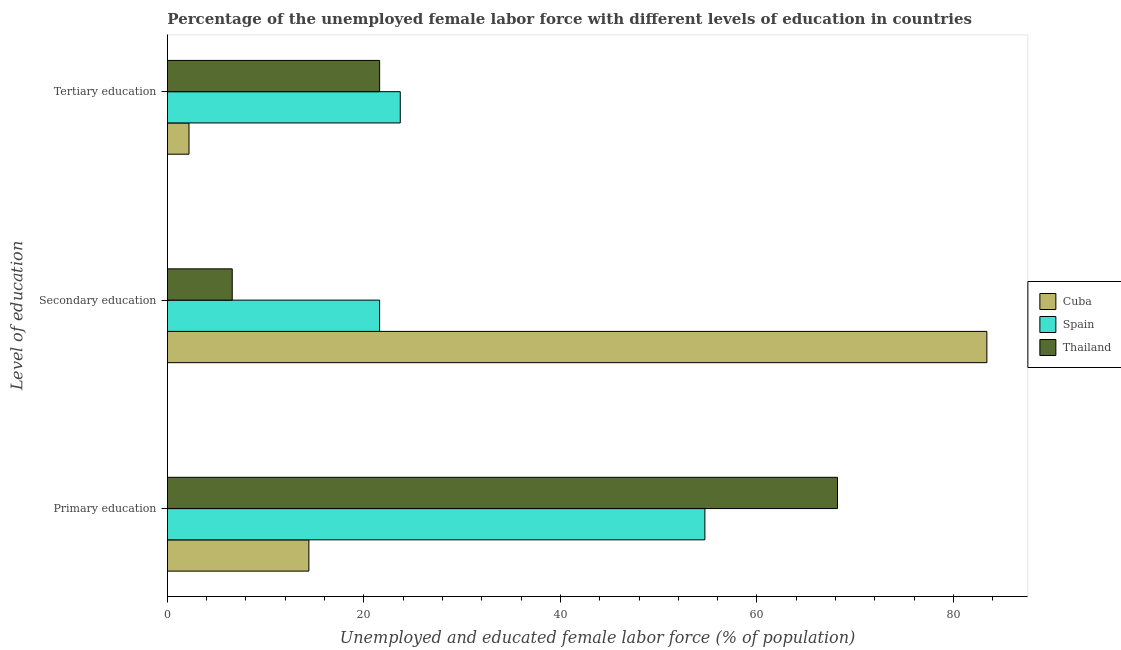How many groups of bars are there?
Give a very brief answer. 3. Are the number of bars per tick equal to the number of legend labels?
Offer a terse response. Yes. Are the number of bars on each tick of the Y-axis equal?
Provide a short and direct response. Yes. How many bars are there on the 2nd tick from the bottom?
Offer a terse response. 3. What is the percentage of female labor force who received tertiary education in Cuba?
Make the answer very short. 2.2. Across all countries, what is the maximum percentage of female labor force who received secondary education?
Offer a very short reply. 83.4. Across all countries, what is the minimum percentage of female labor force who received tertiary education?
Give a very brief answer. 2.2. In which country was the percentage of female labor force who received primary education maximum?
Your answer should be very brief. Thailand. In which country was the percentage of female labor force who received primary education minimum?
Keep it short and to the point. Cuba. What is the total percentage of female labor force who received primary education in the graph?
Keep it short and to the point. 137.3. What is the difference between the percentage of female labor force who received primary education in Thailand and that in Spain?
Your response must be concise. 13.5. What is the difference between the percentage of female labor force who received primary education in Cuba and the percentage of female labor force who received secondary education in Thailand?
Your response must be concise. 7.8. What is the average percentage of female labor force who received tertiary education per country?
Your answer should be very brief. 15.83. What is the difference between the percentage of female labor force who received secondary education and percentage of female labor force who received tertiary education in Cuba?
Ensure brevity in your answer.  81.2. In how many countries, is the percentage of female labor force who received tertiary education greater than 32 %?
Ensure brevity in your answer.  0. What is the ratio of the percentage of female labor force who received primary education in Spain to that in Cuba?
Your answer should be very brief. 3.8. Is the percentage of female labor force who received tertiary education in Thailand less than that in Spain?
Keep it short and to the point. Yes. What is the difference between the highest and the second highest percentage of female labor force who received primary education?
Provide a succinct answer. 13.5. What is the difference between the highest and the lowest percentage of female labor force who received tertiary education?
Make the answer very short. 21.5. In how many countries, is the percentage of female labor force who received tertiary education greater than the average percentage of female labor force who received tertiary education taken over all countries?
Provide a succinct answer. 2. What does the 1st bar from the top in Secondary education represents?
Provide a succinct answer. Thailand. What does the 3rd bar from the bottom in Tertiary education represents?
Provide a succinct answer. Thailand. How many bars are there?
Keep it short and to the point. 9. Does the graph contain any zero values?
Your answer should be compact. No. Does the graph contain grids?
Give a very brief answer. No. Where does the legend appear in the graph?
Your answer should be very brief. Center right. How many legend labels are there?
Your answer should be compact. 3. What is the title of the graph?
Offer a terse response. Percentage of the unemployed female labor force with different levels of education in countries. Does "Palau" appear as one of the legend labels in the graph?
Ensure brevity in your answer.  No. What is the label or title of the X-axis?
Ensure brevity in your answer.  Unemployed and educated female labor force (% of population). What is the label or title of the Y-axis?
Ensure brevity in your answer.  Level of education. What is the Unemployed and educated female labor force (% of population) of Cuba in Primary education?
Make the answer very short. 14.4. What is the Unemployed and educated female labor force (% of population) of Spain in Primary education?
Provide a succinct answer. 54.7. What is the Unemployed and educated female labor force (% of population) of Thailand in Primary education?
Offer a very short reply. 68.2. What is the Unemployed and educated female labor force (% of population) in Cuba in Secondary education?
Give a very brief answer. 83.4. What is the Unemployed and educated female labor force (% of population) of Spain in Secondary education?
Offer a terse response. 21.6. What is the Unemployed and educated female labor force (% of population) in Thailand in Secondary education?
Offer a very short reply. 6.6. What is the Unemployed and educated female labor force (% of population) in Cuba in Tertiary education?
Offer a very short reply. 2.2. What is the Unemployed and educated female labor force (% of population) in Spain in Tertiary education?
Provide a short and direct response. 23.7. What is the Unemployed and educated female labor force (% of population) in Thailand in Tertiary education?
Make the answer very short. 21.6. Across all Level of education, what is the maximum Unemployed and educated female labor force (% of population) in Cuba?
Offer a terse response. 83.4. Across all Level of education, what is the maximum Unemployed and educated female labor force (% of population) in Spain?
Your answer should be compact. 54.7. Across all Level of education, what is the maximum Unemployed and educated female labor force (% of population) in Thailand?
Offer a very short reply. 68.2. Across all Level of education, what is the minimum Unemployed and educated female labor force (% of population) in Cuba?
Offer a very short reply. 2.2. Across all Level of education, what is the minimum Unemployed and educated female labor force (% of population) in Spain?
Offer a very short reply. 21.6. Across all Level of education, what is the minimum Unemployed and educated female labor force (% of population) in Thailand?
Offer a terse response. 6.6. What is the total Unemployed and educated female labor force (% of population) in Cuba in the graph?
Your answer should be compact. 100. What is the total Unemployed and educated female labor force (% of population) in Thailand in the graph?
Offer a very short reply. 96.4. What is the difference between the Unemployed and educated female labor force (% of population) in Cuba in Primary education and that in Secondary education?
Your answer should be very brief. -69. What is the difference between the Unemployed and educated female labor force (% of population) of Spain in Primary education and that in Secondary education?
Your answer should be very brief. 33.1. What is the difference between the Unemployed and educated female labor force (% of population) of Thailand in Primary education and that in Secondary education?
Make the answer very short. 61.6. What is the difference between the Unemployed and educated female labor force (% of population) of Cuba in Primary education and that in Tertiary education?
Offer a terse response. 12.2. What is the difference between the Unemployed and educated female labor force (% of population) in Thailand in Primary education and that in Tertiary education?
Provide a short and direct response. 46.6. What is the difference between the Unemployed and educated female labor force (% of population) in Cuba in Secondary education and that in Tertiary education?
Provide a succinct answer. 81.2. What is the difference between the Unemployed and educated female labor force (% of population) of Cuba in Primary education and the Unemployed and educated female labor force (% of population) of Spain in Secondary education?
Your answer should be very brief. -7.2. What is the difference between the Unemployed and educated female labor force (% of population) in Cuba in Primary education and the Unemployed and educated female labor force (% of population) in Thailand in Secondary education?
Keep it short and to the point. 7.8. What is the difference between the Unemployed and educated female labor force (% of population) in Spain in Primary education and the Unemployed and educated female labor force (% of population) in Thailand in Secondary education?
Make the answer very short. 48.1. What is the difference between the Unemployed and educated female labor force (% of population) in Spain in Primary education and the Unemployed and educated female labor force (% of population) in Thailand in Tertiary education?
Give a very brief answer. 33.1. What is the difference between the Unemployed and educated female labor force (% of population) of Cuba in Secondary education and the Unemployed and educated female labor force (% of population) of Spain in Tertiary education?
Offer a very short reply. 59.7. What is the difference between the Unemployed and educated female labor force (% of population) of Cuba in Secondary education and the Unemployed and educated female labor force (% of population) of Thailand in Tertiary education?
Ensure brevity in your answer.  61.8. What is the difference between the Unemployed and educated female labor force (% of population) in Spain in Secondary education and the Unemployed and educated female labor force (% of population) in Thailand in Tertiary education?
Offer a terse response. 0. What is the average Unemployed and educated female labor force (% of population) of Cuba per Level of education?
Your response must be concise. 33.33. What is the average Unemployed and educated female labor force (% of population) in Spain per Level of education?
Provide a short and direct response. 33.33. What is the average Unemployed and educated female labor force (% of population) of Thailand per Level of education?
Your answer should be very brief. 32.13. What is the difference between the Unemployed and educated female labor force (% of population) in Cuba and Unemployed and educated female labor force (% of population) in Spain in Primary education?
Ensure brevity in your answer.  -40.3. What is the difference between the Unemployed and educated female labor force (% of population) in Cuba and Unemployed and educated female labor force (% of population) in Thailand in Primary education?
Your answer should be very brief. -53.8. What is the difference between the Unemployed and educated female labor force (% of population) in Spain and Unemployed and educated female labor force (% of population) in Thailand in Primary education?
Offer a very short reply. -13.5. What is the difference between the Unemployed and educated female labor force (% of population) in Cuba and Unemployed and educated female labor force (% of population) in Spain in Secondary education?
Offer a very short reply. 61.8. What is the difference between the Unemployed and educated female labor force (% of population) in Cuba and Unemployed and educated female labor force (% of population) in Thailand in Secondary education?
Your answer should be compact. 76.8. What is the difference between the Unemployed and educated female labor force (% of population) in Spain and Unemployed and educated female labor force (% of population) in Thailand in Secondary education?
Make the answer very short. 15. What is the difference between the Unemployed and educated female labor force (% of population) of Cuba and Unemployed and educated female labor force (% of population) of Spain in Tertiary education?
Provide a short and direct response. -21.5. What is the difference between the Unemployed and educated female labor force (% of population) of Cuba and Unemployed and educated female labor force (% of population) of Thailand in Tertiary education?
Your response must be concise. -19.4. What is the difference between the Unemployed and educated female labor force (% of population) of Spain and Unemployed and educated female labor force (% of population) of Thailand in Tertiary education?
Provide a short and direct response. 2.1. What is the ratio of the Unemployed and educated female labor force (% of population) of Cuba in Primary education to that in Secondary education?
Offer a very short reply. 0.17. What is the ratio of the Unemployed and educated female labor force (% of population) of Spain in Primary education to that in Secondary education?
Ensure brevity in your answer.  2.53. What is the ratio of the Unemployed and educated female labor force (% of population) of Thailand in Primary education to that in Secondary education?
Provide a succinct answer. 10.33. What is the ratio of the Unemployed and educated female labor force (% of population) of Cuba in Primary education to that in Tertiary education?
Provide a succinct answer. 6.55. What is the ratio of the Unemployed and educated female labor force (% of population) of Spain in Primary education to that in Tertiary education?
Provide a succinct answer. 2.31. What is the ratio of the Unemployed and educated female labor force (% of population) in Thailand in Primary education to that in Tertiary education?
Provide a short and direct response. 3.16. What is the ratio of the Unemployed and educated female labor force (% of population) in Cuba in Secondary education to that in Tertiary education?
Your response must be concise. 37.91. What is the ratio of the Unemployed and educated female labor force (% of population) in Spain in Secondary education to that in Tertiary education?
Provide a succinct answer. 0.91. What is the ratio of the Unemployed and educated female labor force (% of population) in Thailand in Secondary education to that in Tertiary education?
Make the answer very short. 0.31. What is the difference between the highest and the second highest Unemployed and educated female labor force (% of population) of Cuba?
Your answer should be compact. 69. What is the difference between the highest and the second highest Unemployed and educated female labor force (% of population) in Spain?
Your response must be concise. 31. What is the difference between the highest and the second highest Unemployed and educated female labor force (% of population) of Thailand?
Offer a very short reply. 46.6. What is the difference between the highest and the lowest Unemployed and educated female labor force (% of population) of Cuba?
Offer a terse response. 81.2. What is the difference between the highest and the lowest Unemployed and educated female labor force (% of population) in Spain?
Offer a terse response. 33.1. What is the difference between the highest and the lowest Unemployed and educated female labor force (% of population) in Thailand?
Your response must be concise. 61.6. 